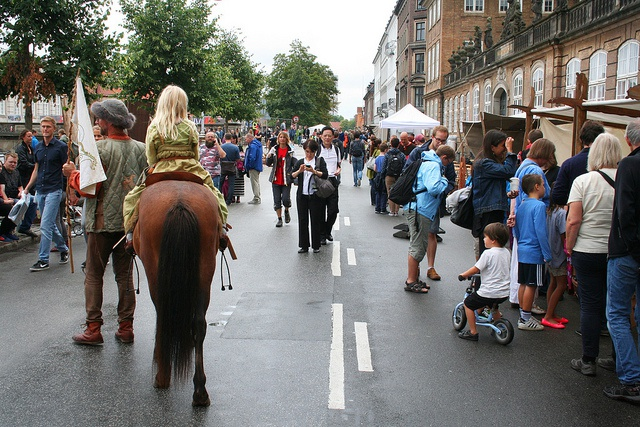Describe the objects in this image and their specific colors. I can see people in black, gray, navy, and blue tones, horse in black, maroon, gray, and brown tones, people in black, gray, and maroon tones, people in black, darkgray, lightgray, and gray tones, and people in black, olive, tan, and beige tones in this image. 